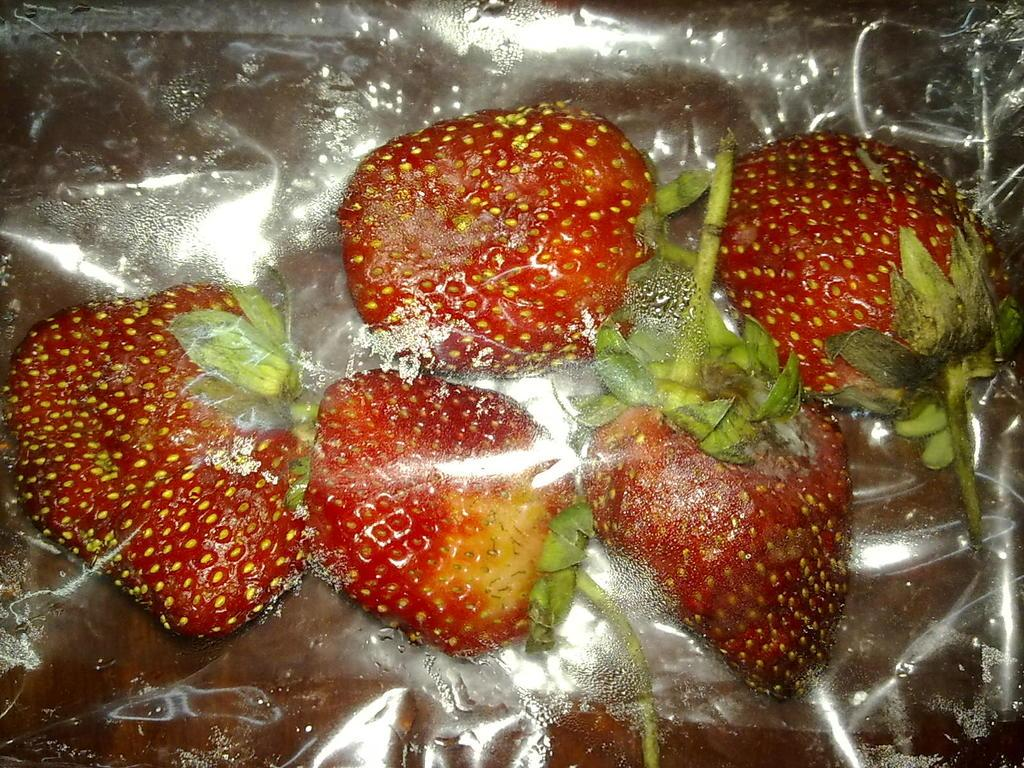What type of fruit is present in the image? There are strawberries in the image. How are the strawberries being stored or protected? The strawberries are in a cover. What type of drum can be seen in the image? There is no drum present in the image; it only features strawberries in a cover. 